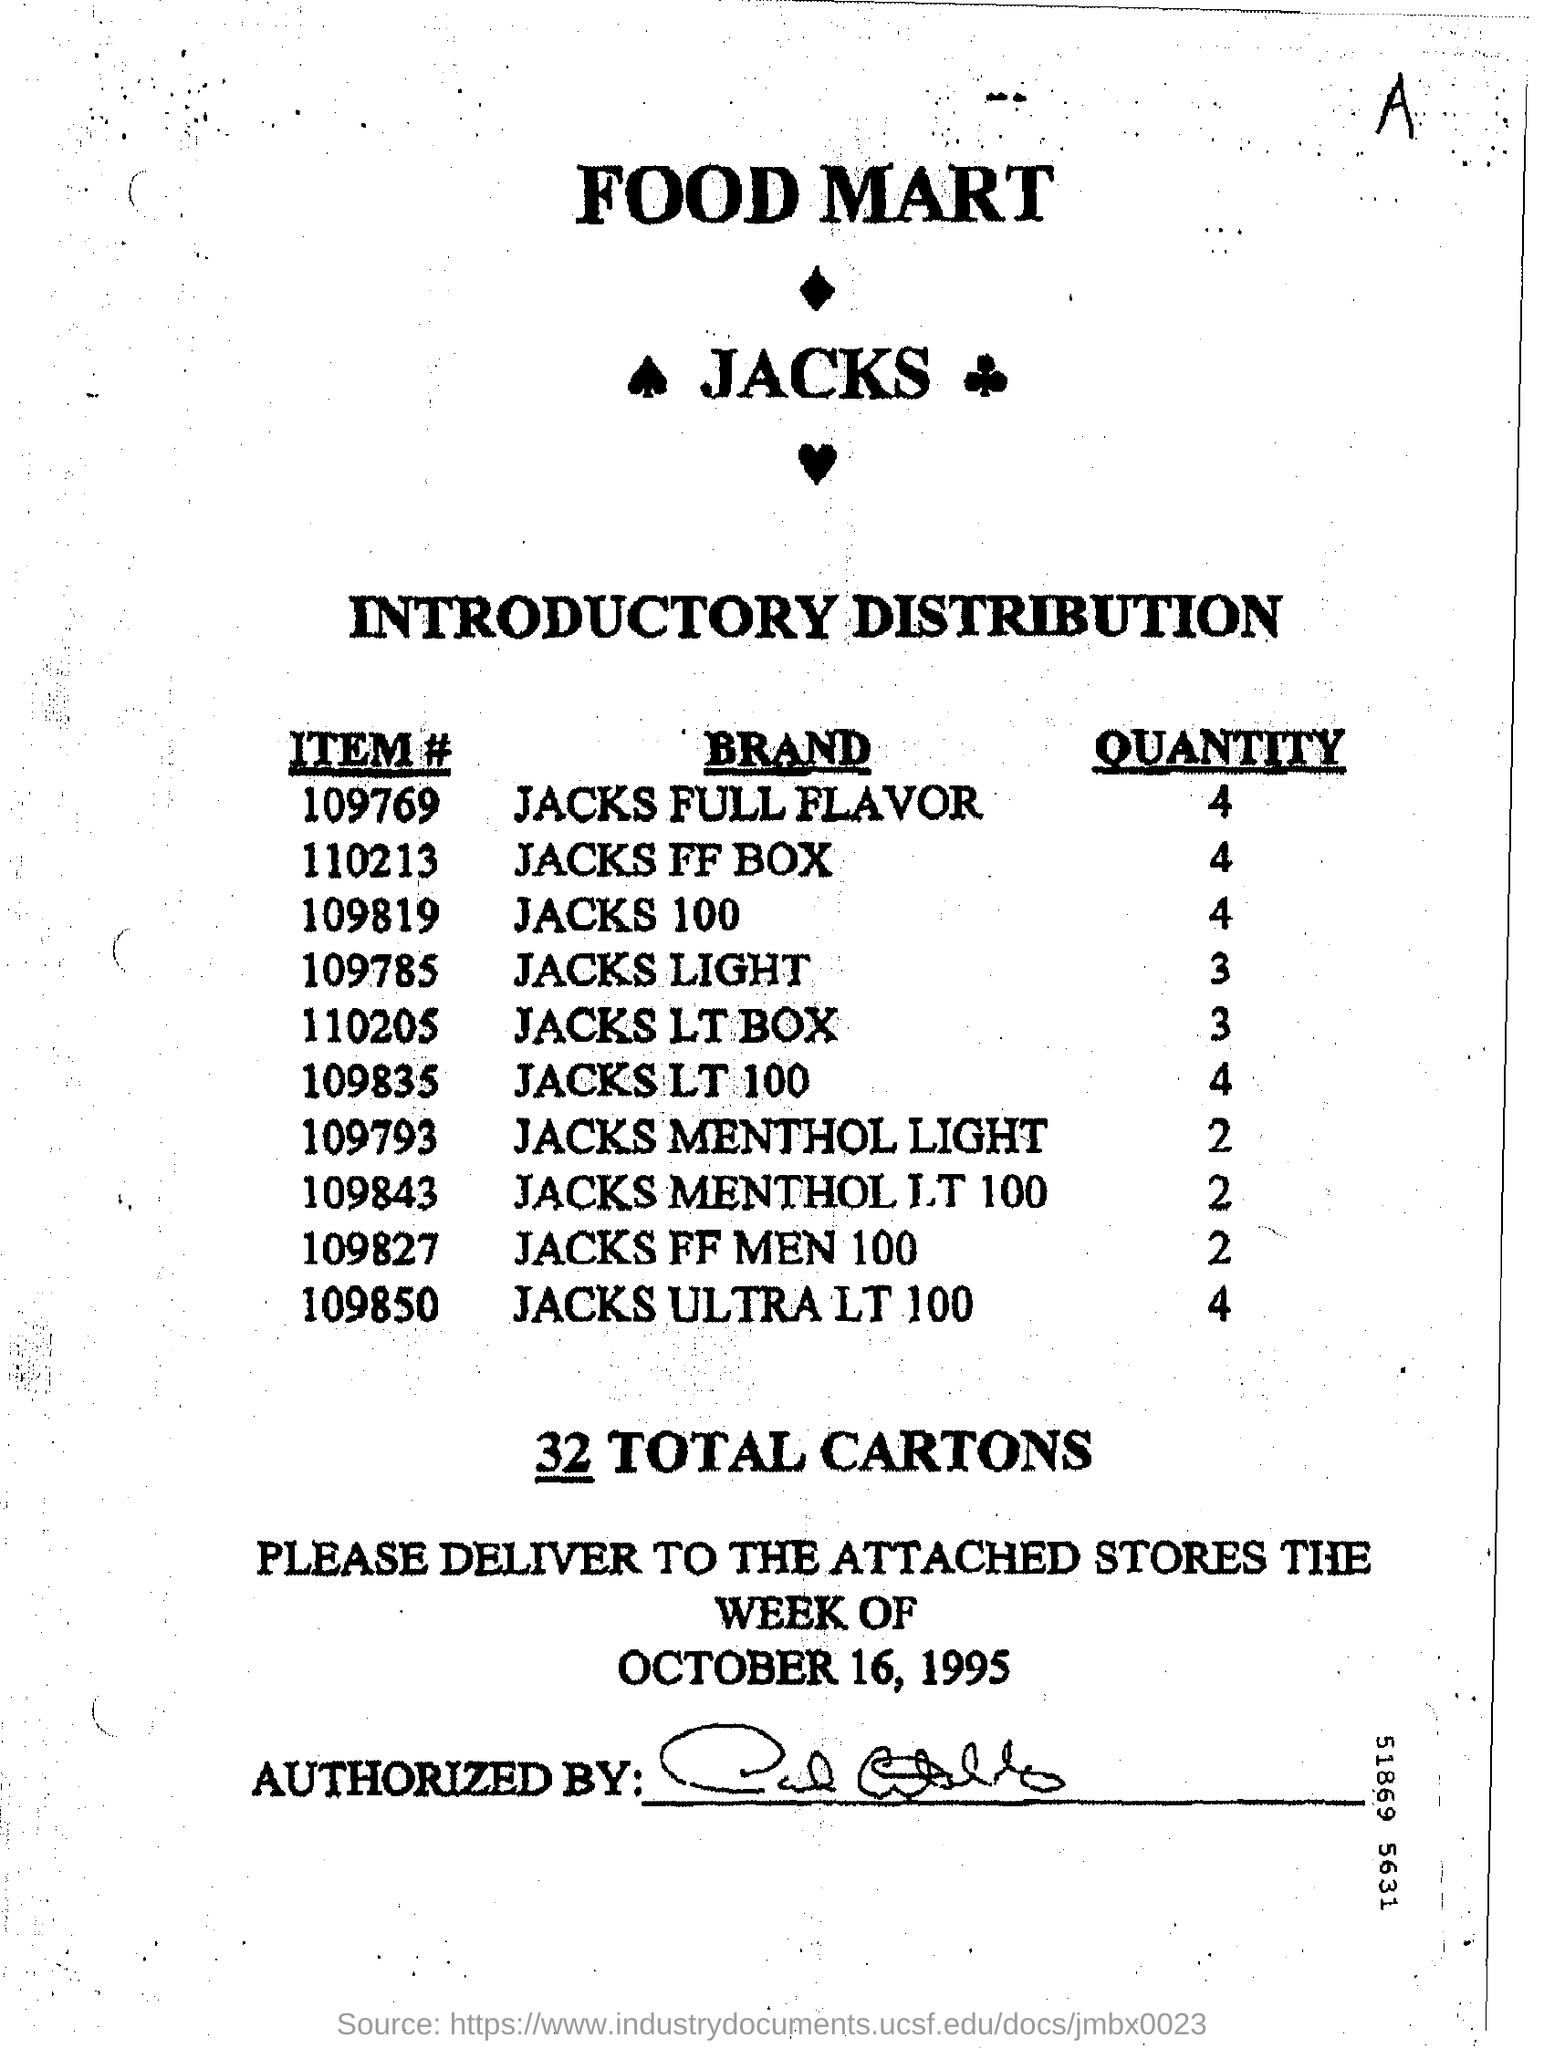List a handful of essential elements in this visual. I have 100 jacks and would like to know the quantity of them. The quantity for Jacks light is 3. The item number for Jacks LT 100 is 109835. I'm sorry, but I don't understand what you are asking for. Could you please provide more context or clarify your question? The total number of cartons is 32. 